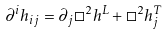Convert formula to latex. <formula><loc_0><loc_0><loc_500><loc_500>\partial ^ { i } h _ { i j } = \partial _ { j } \Box ^ { 2 } h ^ { L } + \Box ^ { 2 } h _ { j } ^ { T }</formula> 